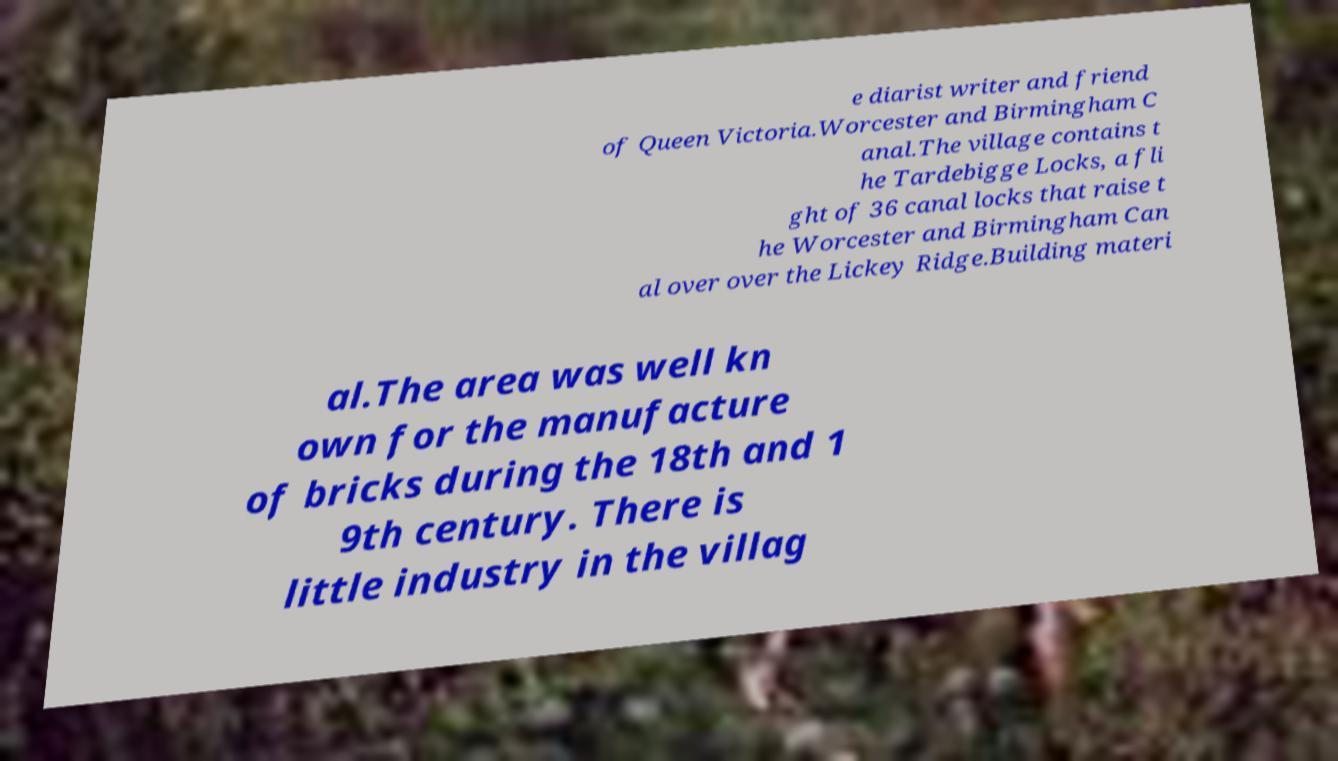Can you accurately transcribe the text from the provided image for me? e diarist writer and friend of Queen Victoria.Worcester and Birmingham C anal.The village contains t he Tardebigge Locks, a fli ght of 36 canal locks that raise t he Worcester and Birmingham Can al over over the Lickey Ridge.Building materi al.The area was well kn own for the manufacture of bricks during the 18th and 1 9th century. There is little industry in the villag 